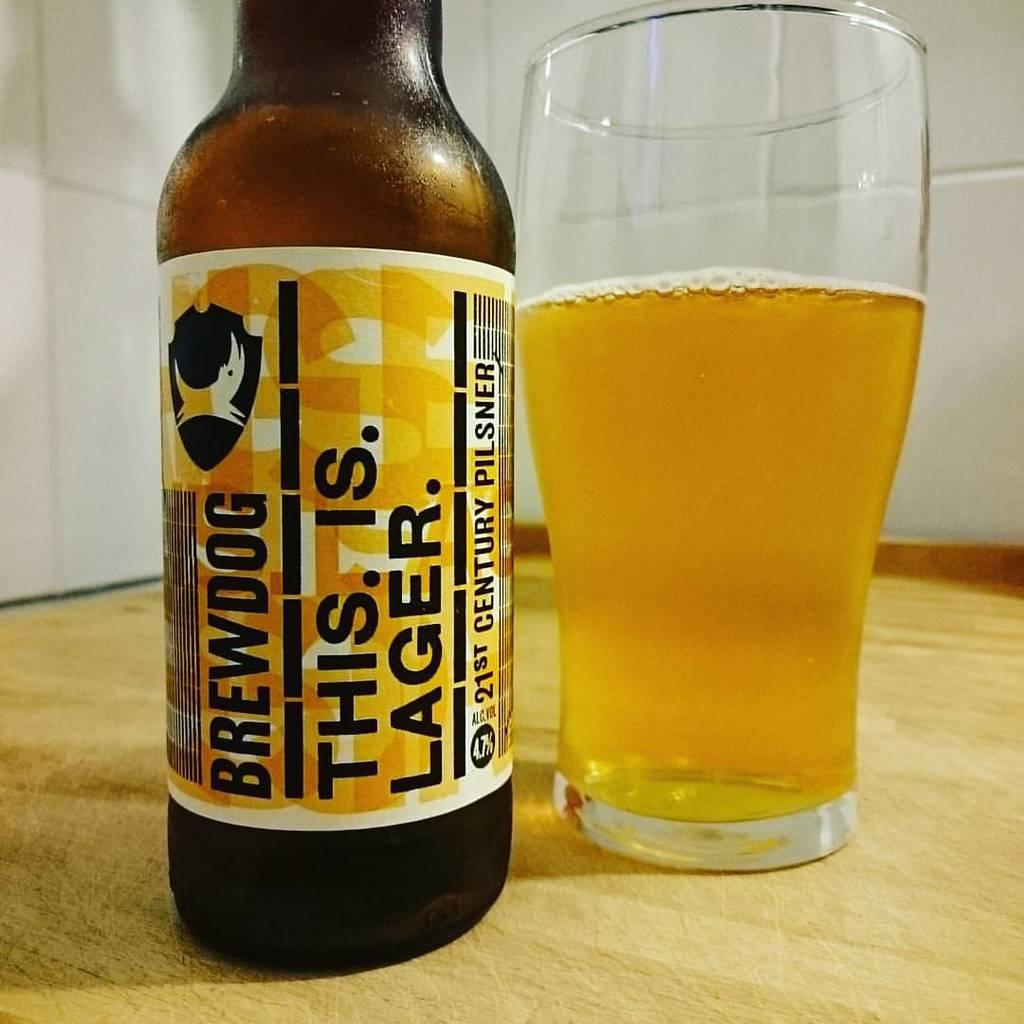What is on the bottle that is visible in the image? There is a label on the bottle in the image. Where is the bottle located in the image? The bottle is on a table in the image. What is in the glass that is visible in the image? There is a drink in the glass in the image. Where is the glass located in the image? The glass is on a table in the image. Reasoning: Let' Let's think step by step in order to produce the conversation. We start by identifying the main subjects in the image, which are the bottle and the glass. Then, we describe the specific features of each item, such as the label on the bottle and the drink in the glass. Finally, we mention the location of these items, which is on a table in the image. Absurd Question/Answer: What type of chalk is being used to write on the table in the image? There is no chalk or writing on the table in the image. Is there a locket hanging from the bottle in the image? There is no locket present in the image. What type of chalk is being used to write on the table in the image? There is no chalk or writing on the table in the image. Is there a locket hanging from the bottle in the image? There is no locket present in the image. 